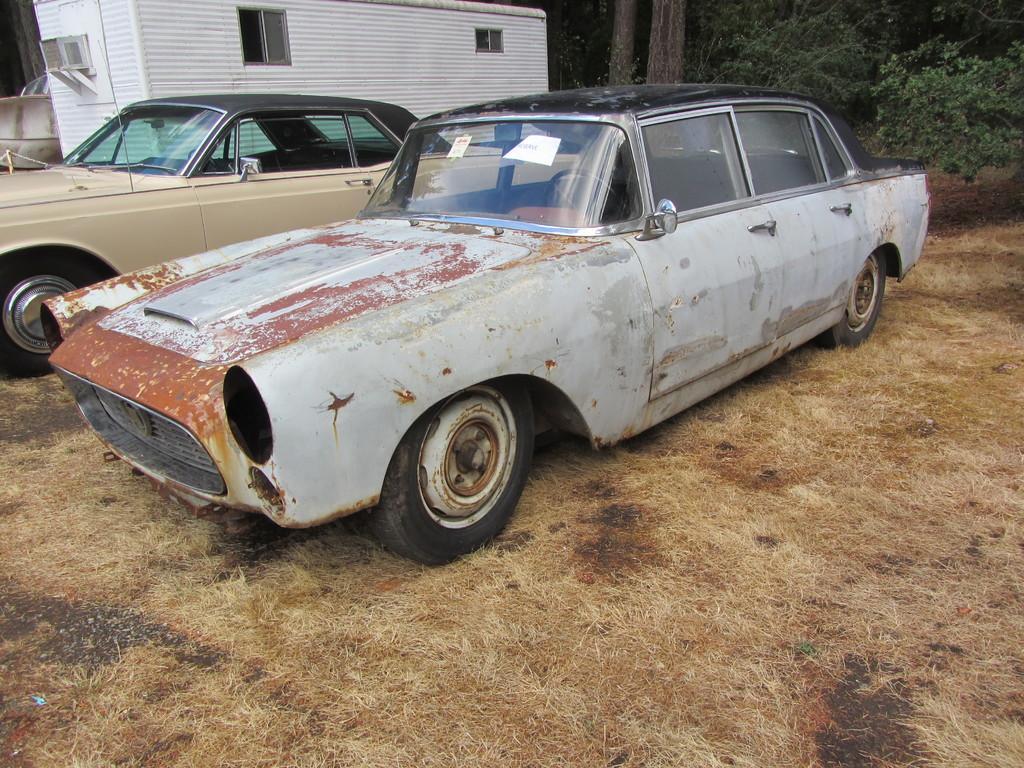Could you give a brief overview of what you see in this image? In this picture we can see two cars on a dry grass. There is a house and few plants in the background. 